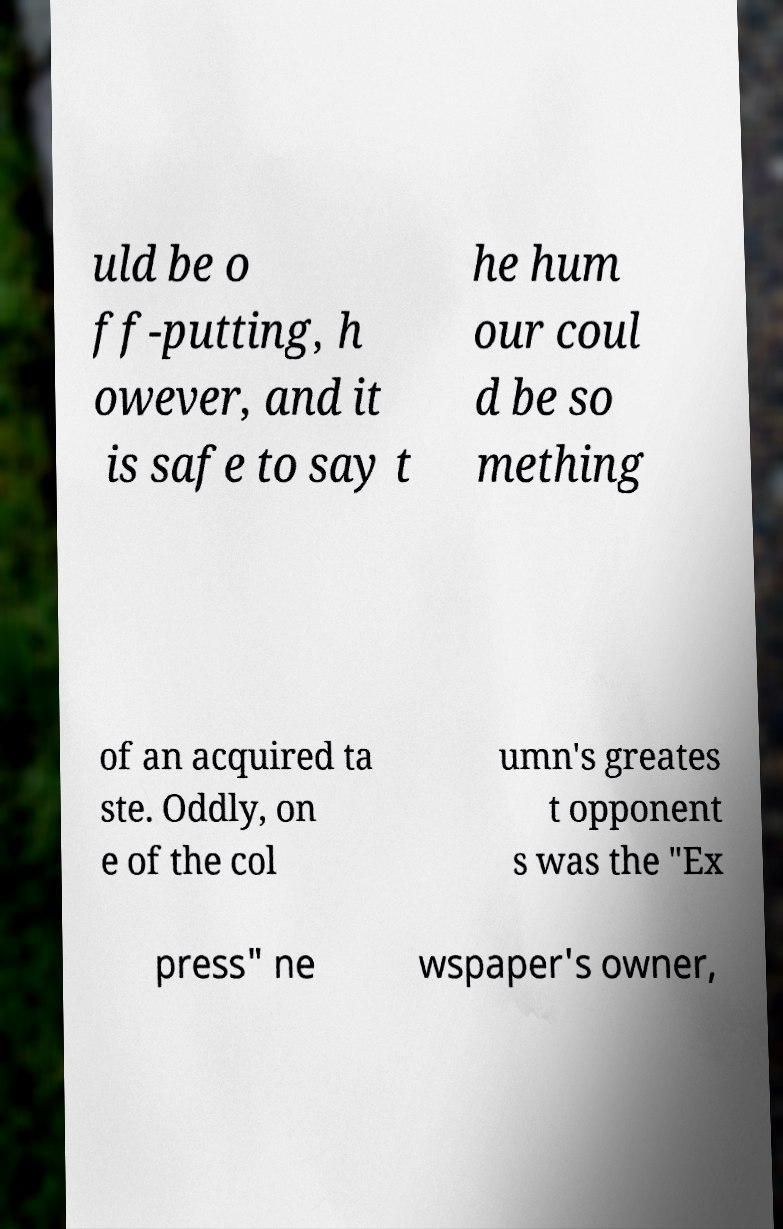Can you read and provide the text displayed in the image?This photo seems to have some interesting text. Can you extract and type it out for me? uld be o ff-putting, h owever, and it is safe to say t he hum our coul d be so mething of an acquired ta ste. Oddly, on e of the col umn's greates t opponent s was the "Ex press" ne wspaper's owner, 